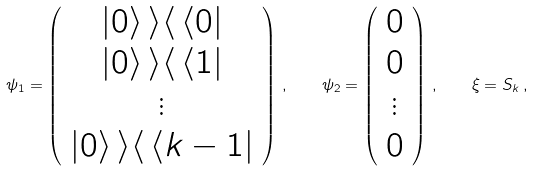<formula> <loc_0><loc_0><loc_500><loc_500>\psi _ { 1 } = \left ( \begin{array} { c } { | 0 \rangle \, \rangle \langle \, \langle 0 | } \\ { | 0 \rangle \, \rangle \langle \, \langle 1 | } \\ { \vdots } \\ { | 0 \rangle \, \rangle \langle \, \langle k - 1 | } \end{array} \right ) \, , \quad \psi _ { 2 } = \left ( \begin{array} { c } { 0 } \\ { 0 } \\ { \vdots } \\ { 0 } \end{array} \right ) \, , \quad \xi = S _ { k } \, ,</formula> 